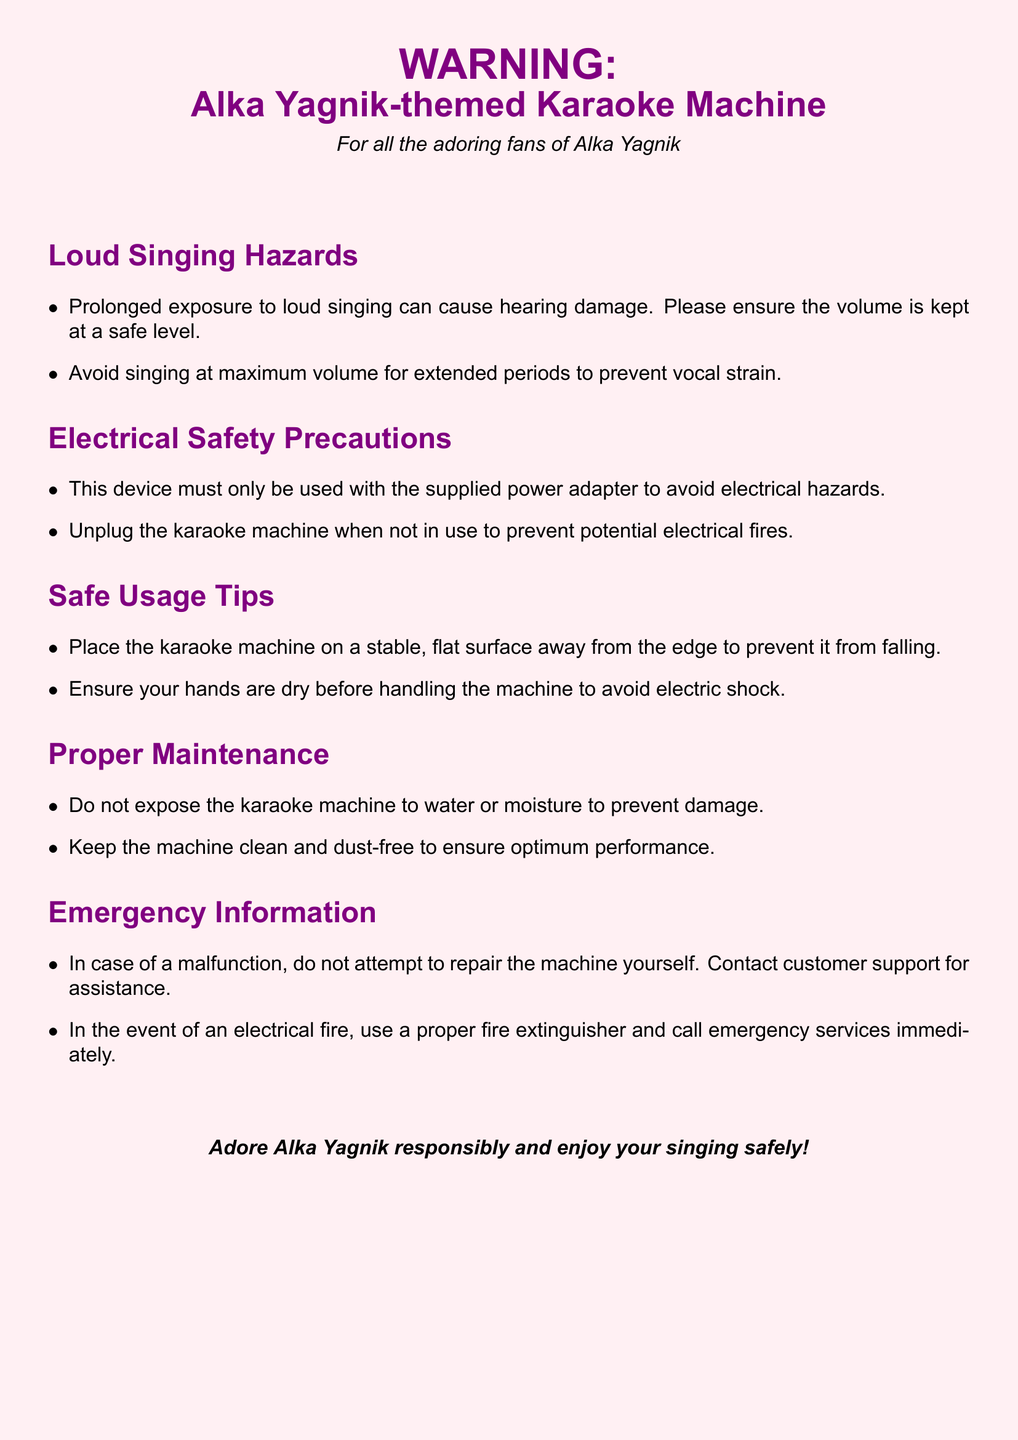what is the primary color of the document background? The document background is tinted pink, which is described as "alkapink" in the document.
Answer: alkapink who is the karaoke machine themed after? The karaoke machine is themed after a well-known Indian playback singer mentioned in the title.
Answer: Alka Yagnik what should be done when the karaoke machine is not in use? The document specifies an action to prevent potential hazards when not using the device.
Answer: Unplug how can one prevent vocal strain during singing? The document provides a recommendation regarding volume levels to avoid strain.
Answer: Avoid maximum volume what type of surface should the karaoke machine be placed on? The document suggests a type of environment to ensure the device's stability during use.
Answer: Stable, flat surface what should you do if the karaoke machine malfunctions? The document instructs a specific action to take in case of a malfunction for safety.
Answer: Contact customer support what should be kept dry to avoid electric shock? The document advises a specific condition related to user safety while handling the machine.
Answer: Hands how often should the karaoke machine be kept clean? Although this detail is not explicitly mentioned in the document, it implies regular care for better performance.
Answer: Regularly 